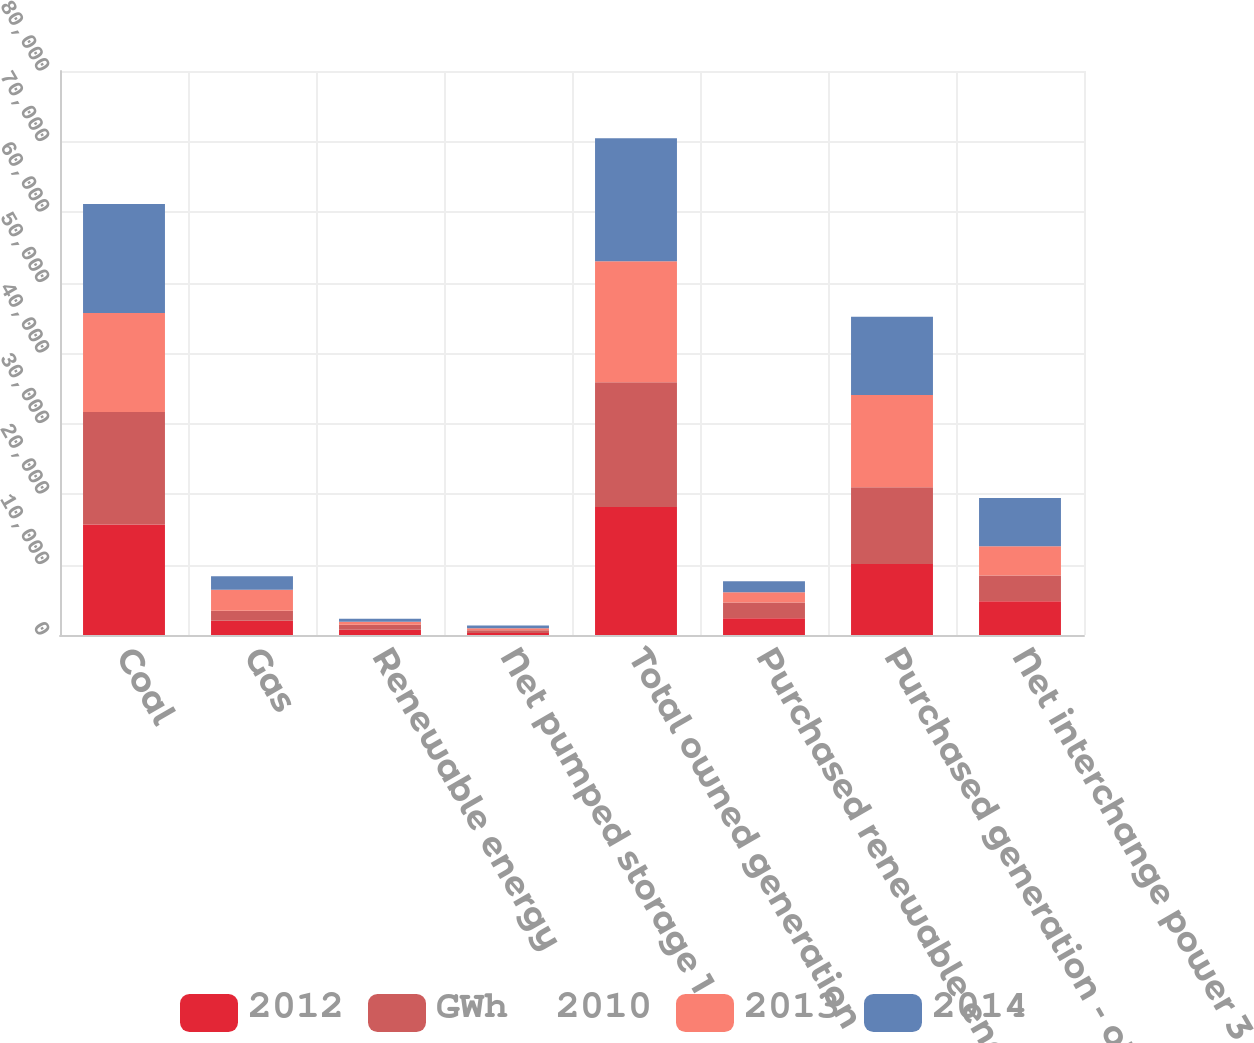Convert chart to OTSL. <chart><loc_0><loc_0><loc_500><loc_500><stacked_bar_chart><ecel><fcel>Coal<fcel>Gas<fcel>Renewable energy<fcel>Net pumped storage 1<fcel>Total owned generation<fcel>Purchased renewable energy 2<fcel>Purchased generation - other 2<fcel>Net interchange power 3<nl><fcel>2012<fcel>15684<fcel>2012<fcel>748<fcel>300<fcel>18144<fcel>2366<fcel>10073<fcel>4793<nl><fcel>GWh  2010<fcel>15951<fcel>1415<fcel>704<fcel>371<fcel>17703<fcel>2250<fcel>10871<fcel>3656<nl><fcel>2013<fcel>14027<fcel>3003<fcel>433<fcel>295<fcel>17174<fcel>1435<fcel>13104<fcel>4151<nl><fcel>2014<fcel>15468<fcel>1912<fcel>425<fcel>365<fcel>17447<fcel>1587<fcel>11087<fcel>6825<nl></chart> 